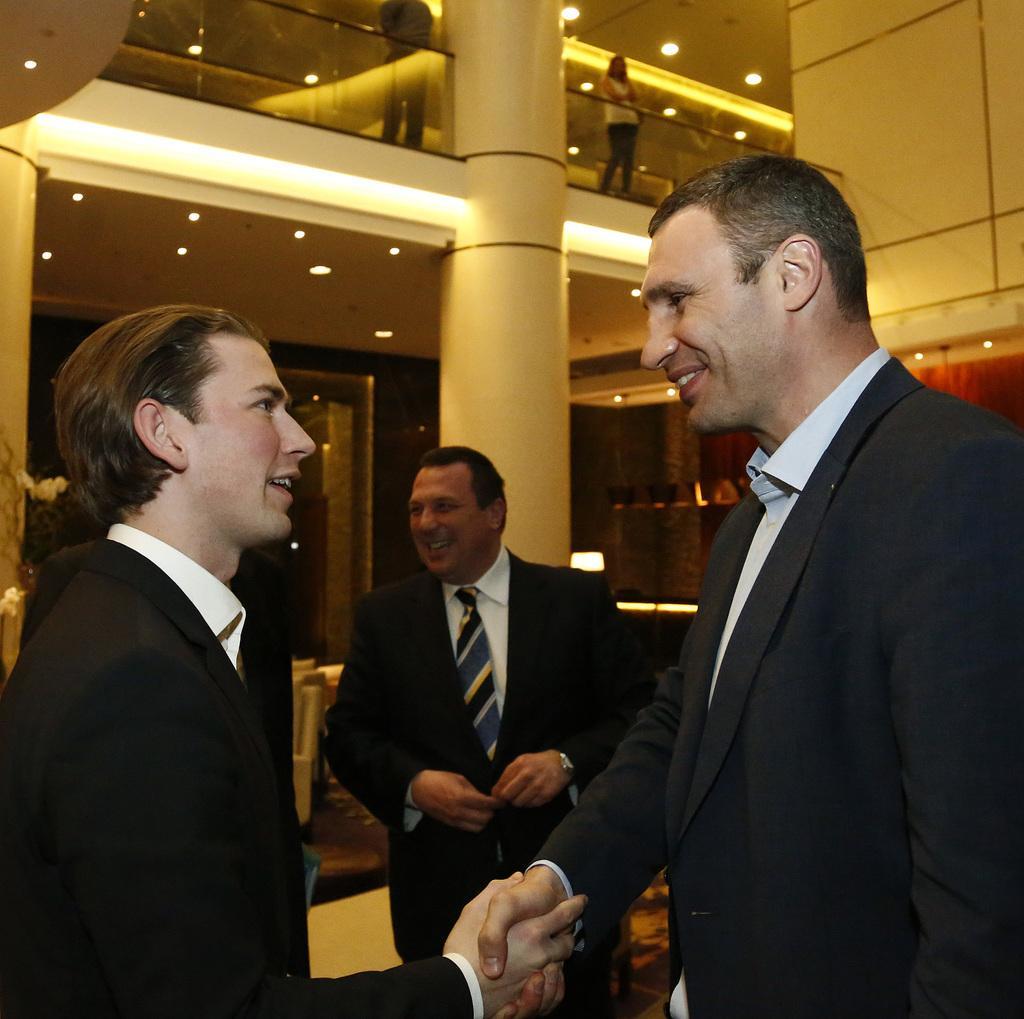Describe this image in one or two sentences. In this picture, we can see a few people, among them two are shaking their hands, we can see the roof with lights, and we can see pillars, and an object on the left side of the picture. 